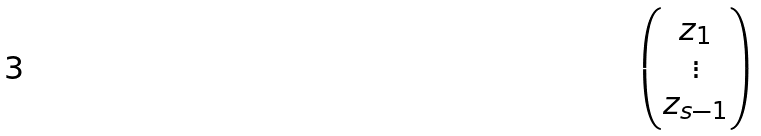<formula> <loc_0><loc_0><loc_500><loc_500>\begin{pmatrix} z _ { 1 } \\ \vdots \\ z _ { s - 1 } \end{pmatrix}</formula> 